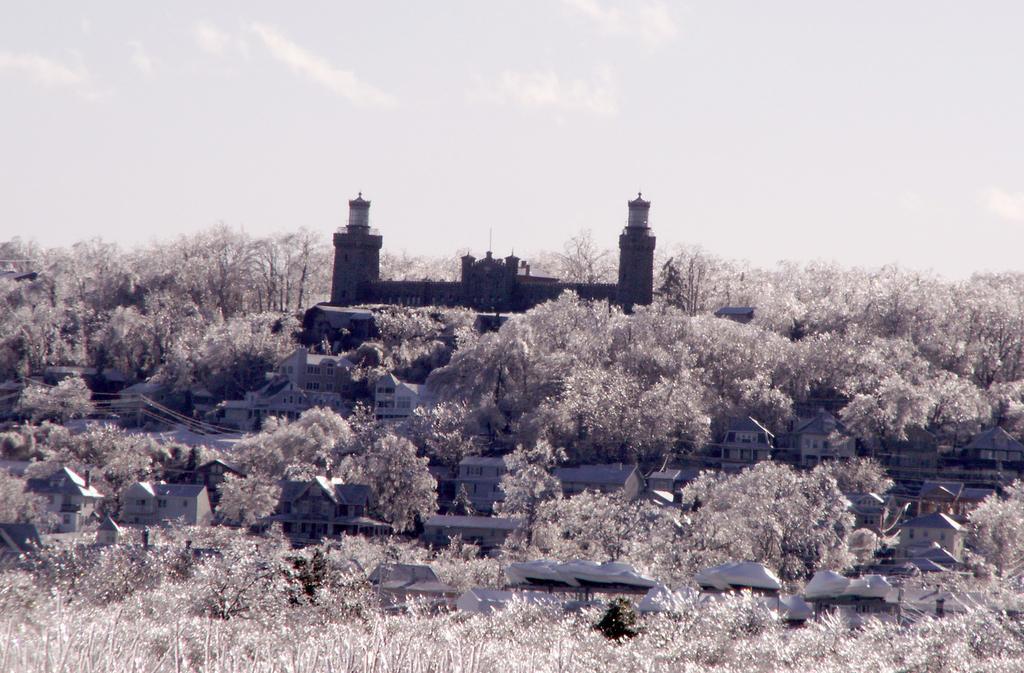How would you summarize this image in a sentence or two? In this picture I can observe building in the middle of the picture. There are some trees around the building. In the background I can observe sky. 